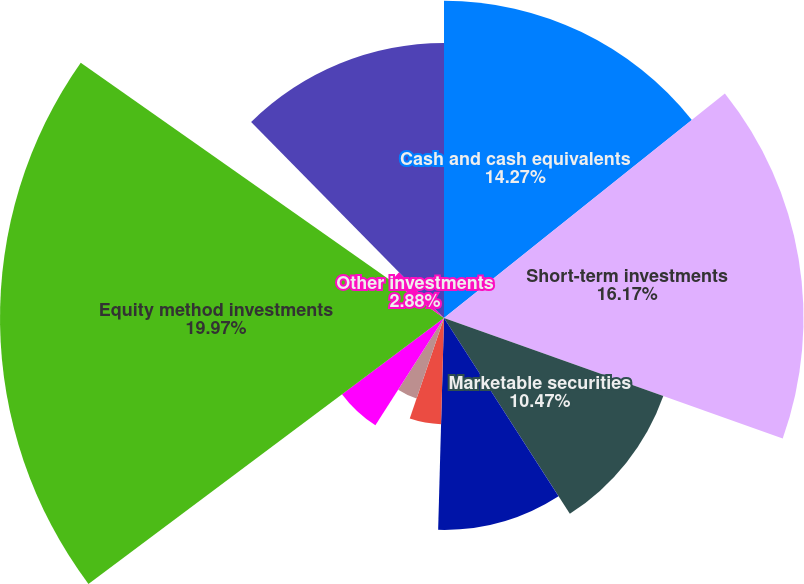Convert chart to OTSL. <chart><loc_0><loc_0><loc_500><loc_500><pie_chart><fcel>Cash and cash equivalents<fcel>Short-term investments<fcel>Marketable securities<fcel>Trade accounts receivable -<fcel>Inventories<fcel>Prepaid expenses and other<fcel>Assets held for sale<fcel>Equity method investments<fcel>Other investments<fcel>Other assets<nl><fcel>14.27%<fcel>16.17%<fcel>10.47%<fcel>9.53%<fcel>4.78%<fcel>3.83%<fcel>5.73%<fcel>19.97%<fcel>2.88%<fcel>12.37%<nl></chart> 